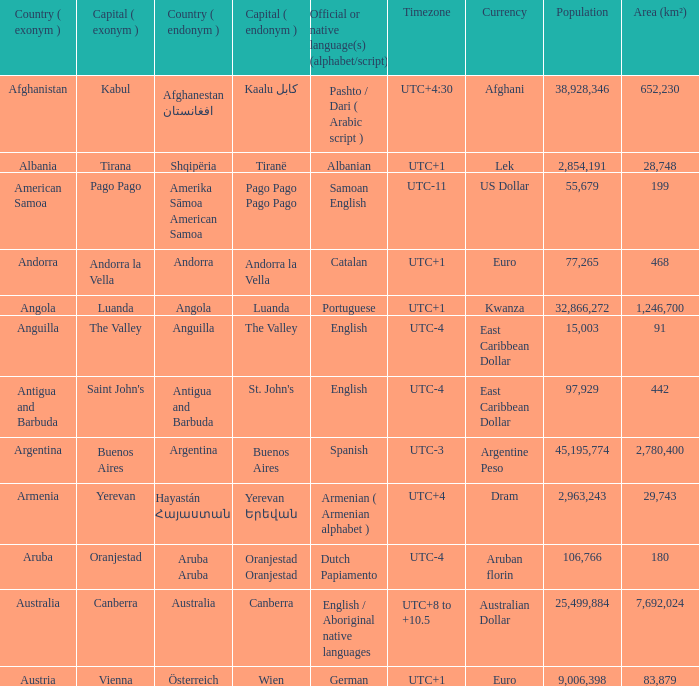How many capital cities does Australia have? 1.0. 